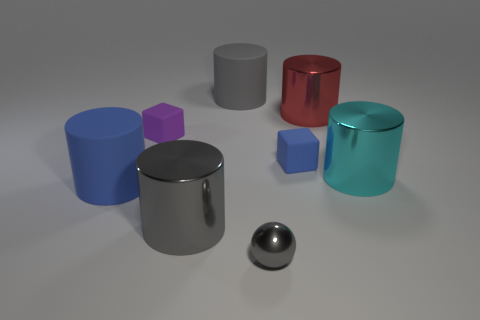Are there more large rubber cylinders that are in front of the red thing than big blue cylinders behind the big blue matte thing?
Provide a short and direct response. Yes. How many big cylinders are the same color as the tiny metallic thing?
Provide a succinct answer. 2. There is a blue cylinder that is made of the same material as the small blue cube; what size is it?
Your response must be concise. Large. What number of objects are large cyan objects to the right of the small purple thing or big green cylinders?
Give a very brief answer. 1. Does the big rubber object behind the tiny blue cube have the same color as the small ball?
Your answer should be compact. Yes. The blue object that is the same shape as the tiny purple thing is what size?
Make the answer very short. Small. There is a tiny rubber block on the left side of the small shiny thing in front of the big matte object that is behind the small blue rubber block; what is its color?
Ensure brevity in your answer.  Purple. Do the large red thing and the large blue cylinder have the same material?
Offer a terse response. No. There is a metal cylinder that is left of the tiny thing to the right of the tiny gray object; are there any matte blocks that are on the right side of it?
Ensure brevity in your answer.  Yes. Is the number of big red shiny cylinders less than the number of small brown shiny blocks?
Make the answer very short. No. 